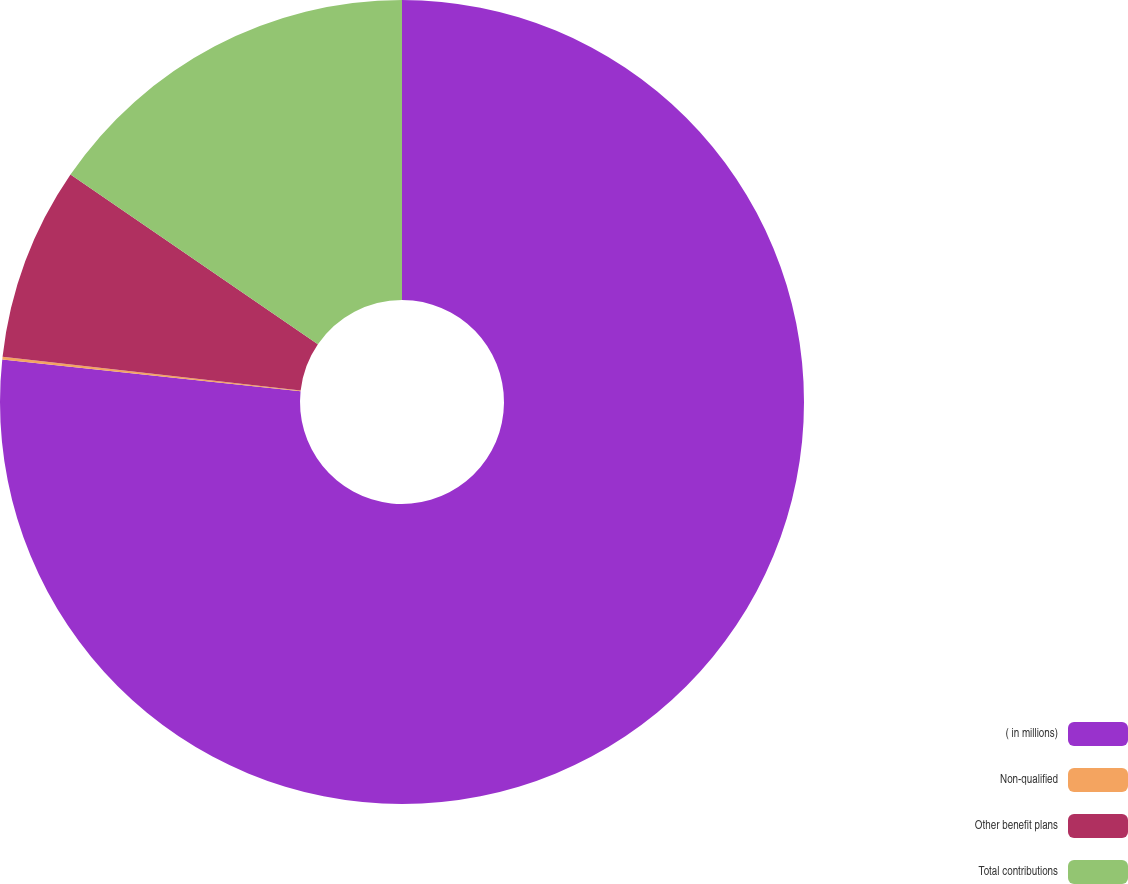<chart> <loc_0><loc_0><loc_500><loc_500><pie_chart><fcel>( in millions)<fcel>Non-qualified<fcel>Other benefit plans<fcel>Total contributions<nl><fcel>76.69%<fcel>0.11%<fcel>7.77%<fcel>15.43%<nl></chart> 